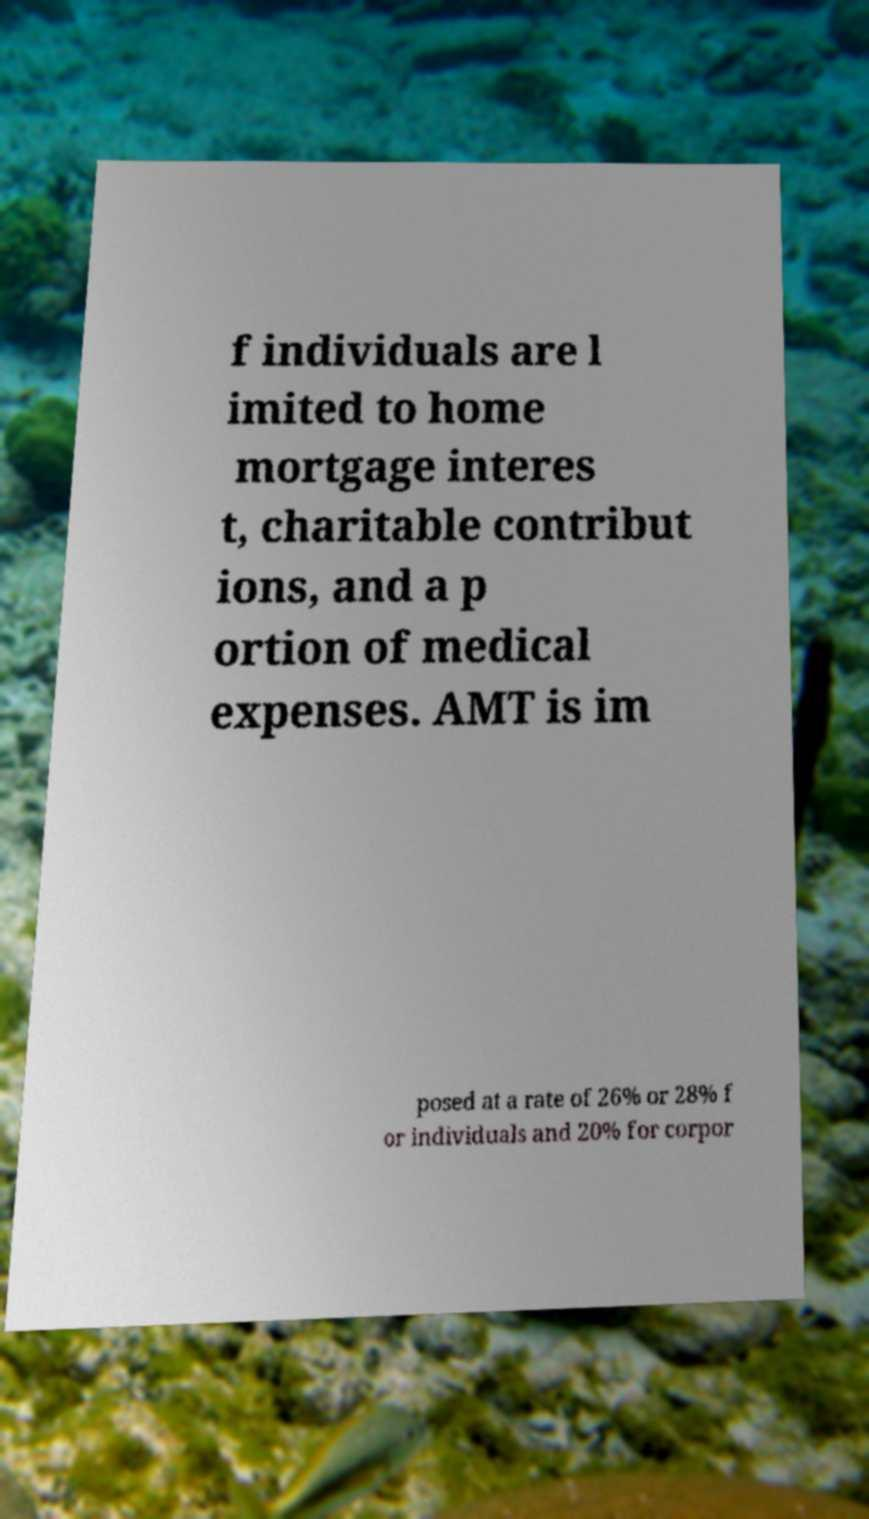Could you assist in decoding the text presented in this image and type it out clearly? f individuals are l imited to home mortgage interes t, charitable contribut ions, and a p ortion of medical expenses. AMT is im posed at a rate of 26% or 28% f or individuals and 20% for corpor 